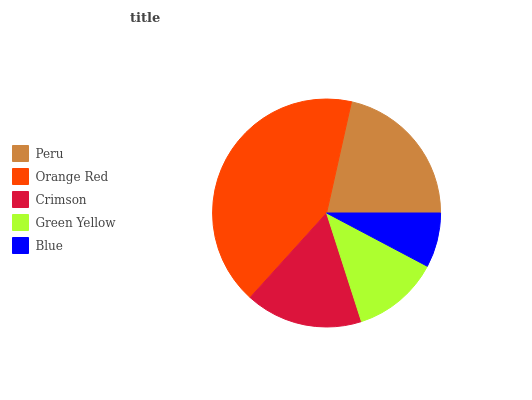Is Blue the minimum?
Answer yes or no. Yes. Is Orange Red the maximum?
Answer yes or no. Yes. Is Crimson the minimum?
Answer yes or no. No. Is Crimson the maximum?
Answer yes or no. No. Is Orange Red greater than Crimson?
Answer yes or no. Yes. Is Crimson less than Orange Red?
Answer yes or no. Yes. Is Crimson greater than Orange Red?
Answer yes or no. No. Is Orange Red less than Crimson?
Answer yes or no. No. Is Crimson the high median?
Answer yes or no. Yes. Is Crimson the low median?
Answer yes or no. Yes. Is Blue the high median?
Answer yes or no. No. Is Orange Red the low median?
Answer yes or no. No. 